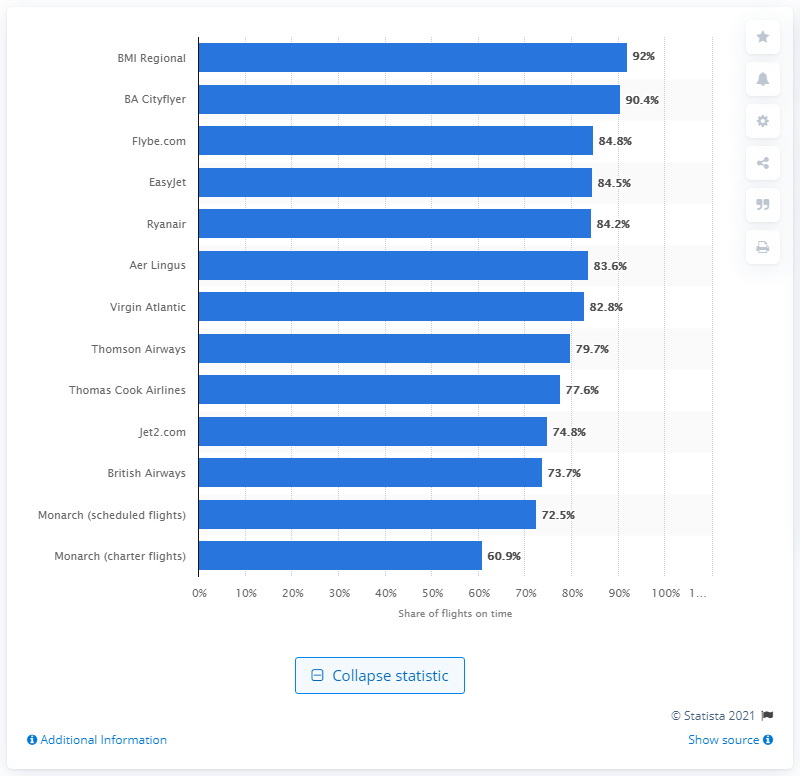Highlight a few significant elements in this photo. The punctuality rate for British Airways was 73.7% in a given period of time. 